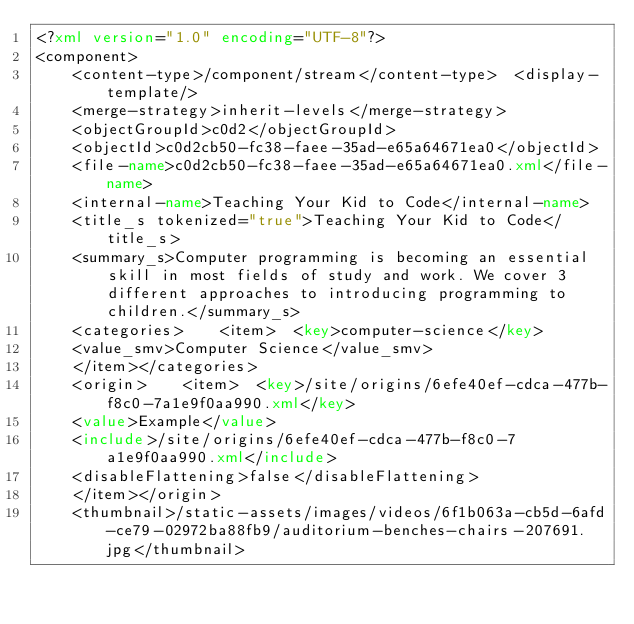Convert code to text. <code><loc_0><loc_0><loc_500><loc_500><_XML_><?xml version="1.0" encoding="UTF-8"?>
<component>
	<content-type>/component/stream</content-type>	<display-template/>
	<merge-strategy>inherit-levels</merge-strategy>
	<objectGroupId>c0d2</objectGroupId>
	<objectId>c0d2cb50-fc38-faee-35ad-e65a64671ea0</objectId>
	<file-name>c0d2cb50-fc38-faee-35ad-e65a64671ea0.xml</file-name>
	<internal-name>Teaching Your Kid to Code</internal-name>
	<title_s tokenized="true">Teaching Your Kid to Code</title_s>
	<summary_s>Computer programming is becoming an essential skill in most fields of study and work. We cover 3 different approaches to introducing programming to children.</summary_s>
	<categories>	<item>	<key>computer-science</key>
	<value_smv>Computer Science</value_smv>
	</item></categories>
	<origin>	<item>	<key>/site/origins/6efe40ef-cdca-477b-f8c0-7a1e9f0aa990.xml</key>
	<value>Example</value>
	<include>/site/origins/6efe40ef-cdca-477b-f8c0-7a1e9f0aa990.xml</include>
	<disableFlattening>false</disableFlattening>
	</item></origin>
	<thumbnail>/static-assets/images/videos/6f1b063a-cb5d-6afd-ce79-02972ba88fb9/auditorium-benches-chairs-207691.jpg</thumbnail></code> 